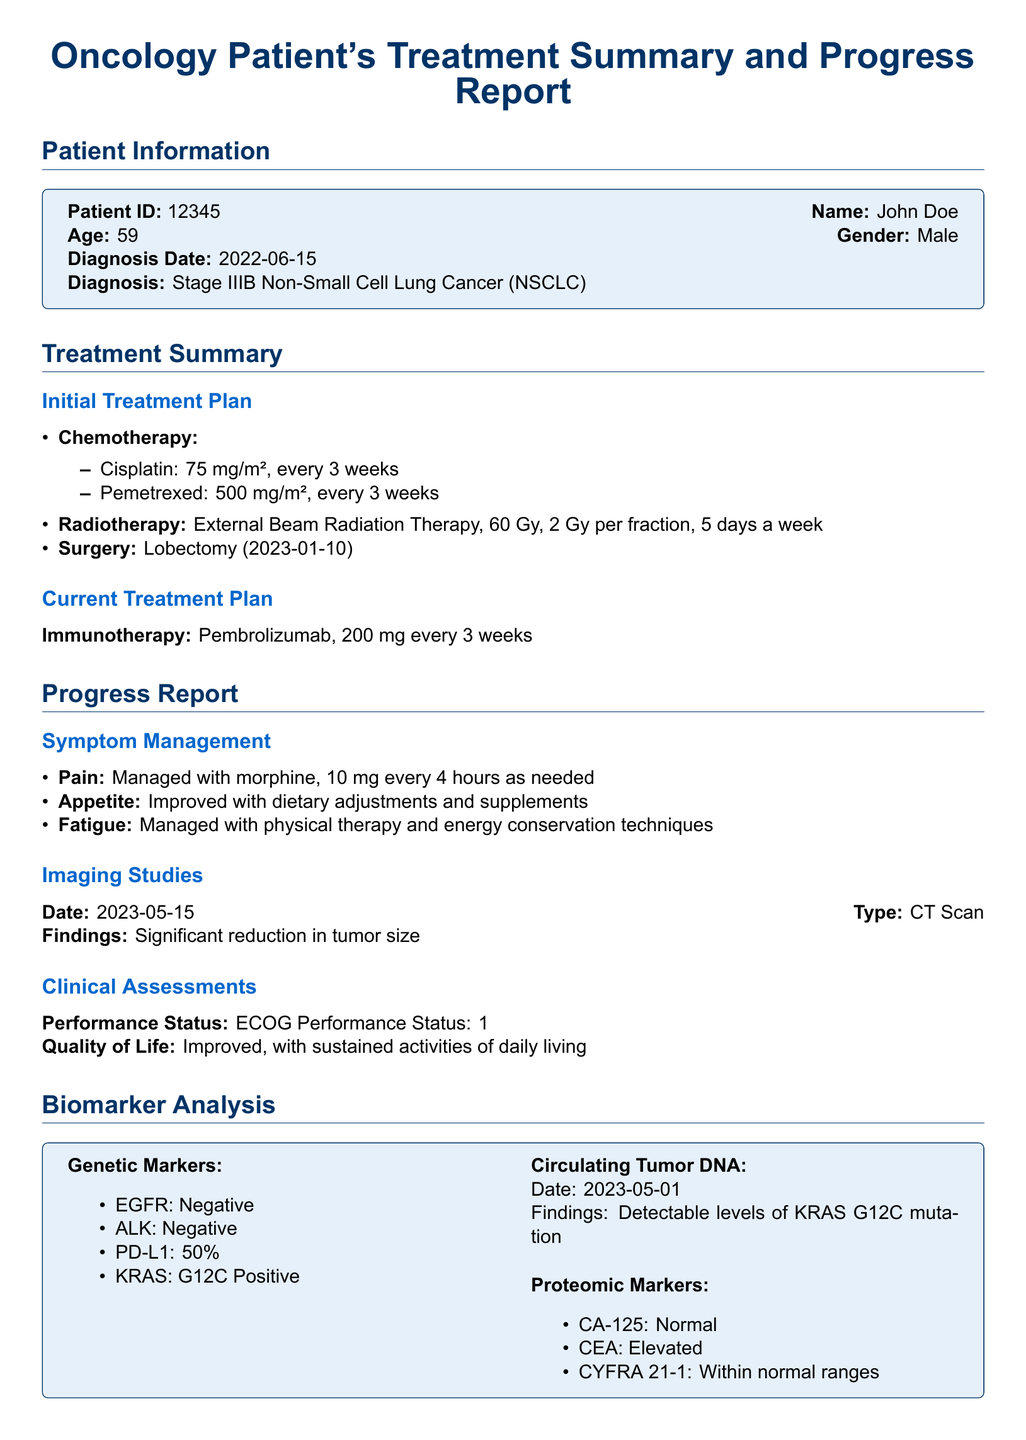What is the patient's age? Patient's age is provided in the Patient Information section of the document.
Answer: 59 What is the diagnosis date? The date of diagnosis is mentioned directly in the Patient Information section.
Answer: 2022-06-15 What is the current treatment plan? The current treatment plan is specifically listed in the Treatment Summary section.
Answer: Pembrolizumab, 200 mg every 3 weeks What imaging study was performed on 2023-05-15? The type of imaging study conducted is recorded in the Progress Report.
Answer: CT Scan What percentage of PD-L1 is noted in the biomarker analysis? The percentage is specified under Genetic Markers in the Biomarker Analysis section.
Answer: 50% What surgical procedure did the patient undergo, and when? The procedure and date of surgery are included under the Initial Treatment Plan.
Answer: Lobectomy (2023-01-10) What is the ECOG Performance Status of the patient? The ECOG Performance Status is explicitly mentioned in the Clinical Assessments section.
Answer: 1 What was found in the circulating tumor DNA analysis? The findings from the circulating tumor DNA assessment are documented in the Biomarker Analysis section.
Answer: Detectable levels of KRAS G12C mutation What symptoms are being managed with morphine? The symptom managed with morphine is indicated in the Symptom Management section.
Answer: Pain What was the result of the CT scan regarding tumor size? The results of the imaging study regarding tumor size are outlined in the Imaging Studies section.
Answer: Significant reduction in tumor size 